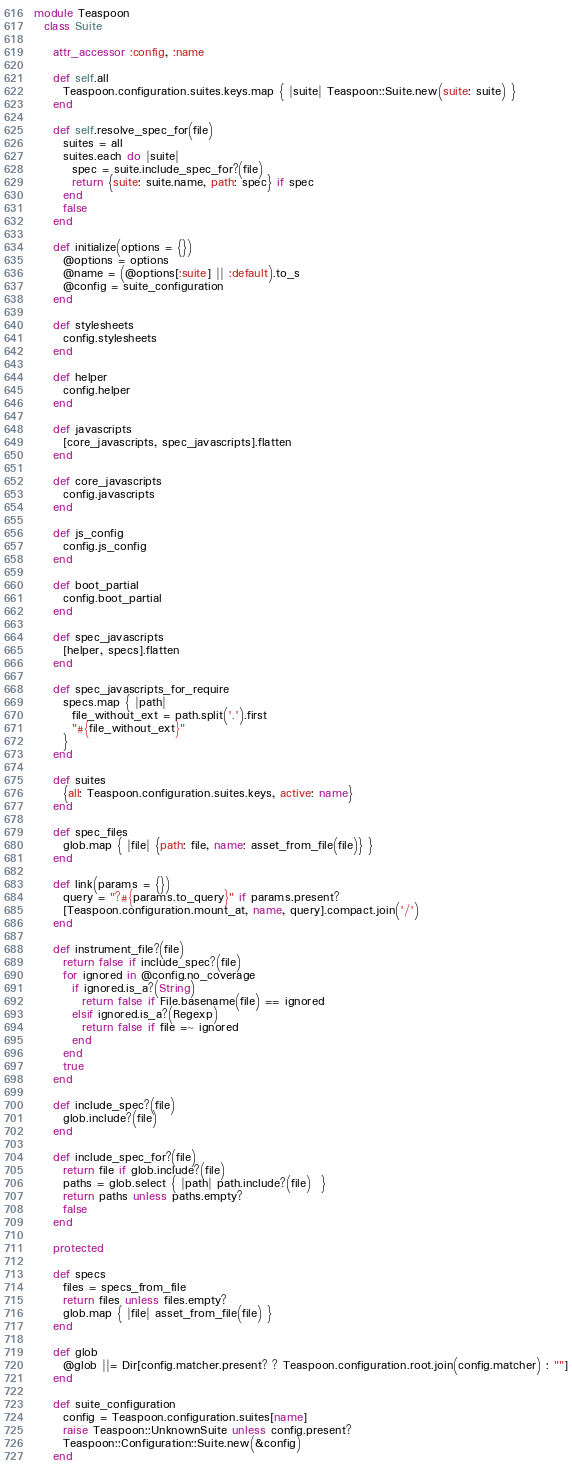<code> <loc_0><loc_0><loc_500><loc_500><_Ruby_>module Teaspoon
  class Suite

    attr_accessor :config, :name

    def self.all
      Teaspoon.configuration.suites.keys.map { |suite| Teaspoon::Suite.new(suite: suite) }
    end

    def self.resolve_spec_for(file)
      suites = all
      suites.each do |suite|
        spec = suite.include_spec_for?(file)
        return {suite: suite.name, path: spec} if spec
      end
      false
    end

    def initialize(options = {})
      @options = options
      @name = (@options[:suite] || :default).to_s
      @config = suite_configuration
    end

    def stylesheets
      config.stylesheets
    end

    def helper
      config.helper
    end

    def javascripts
      [core_javascripts, spec_javascripts].flatten
    end

    def core_javascripts
      config.javascripts
    end

    def js_config
      config.js_config
    end

    def boot_partial
      config.boot_partial
    end

    def spec_javascripts
      [helper, specs].flatten
    end

    def spec_javascripts_for_require
      specs.map { |path|
        file_without_ext = path.split('.').first
        "#{file_without_ext}"
      }
    end

    def suites
      {all: Teaspoon.configuration.suites.keys, active: name}
    end

    def spec_files
      glob.map { |file| {path: file, name: asset_from_file(file)} }
    end

    def link(params = {})
      query = "?#{params.to_query}" if params.present?
      [Teaspoon.configuration.mount_at, name, query].compact.join('/')
    end

    def instrument_file?(file)
      return false if include_spec?(file)
      for ignored in @config.no_coverage
        if ignored.is_a?(String)
          return false if File.basename(file) == ignored
        elsif ignored.is_a?(Regexp)
          return false if file =~ ignored
        end
      end
      true
    end

    def include_spec?(file)
      glob.include?(file)
    end

    def include_spec_for?(file)
      return file if glob.include?(file)
      paths = glob.select { |path| path.include?(file)  }
      return paths unless paths.empty?
      false
    end

    protected

    def specs
      files = specs_from_file
      return files unless files.empty?
      glob.map { |file| asset_from_file(file) }
    end

    def glob
      @glob ||= Dir[config.matcher.present? ? Teaspoon.configuration.root.join(config.matcher) : ""]
    end

    def suite_configuration
      config = Teaspoon.configuration.suites[name]
      raise Teaspoon::UnknownSuite unless config.present?
      Teaspoon::Configuration::Suite.new(&config)
    end
</code> 